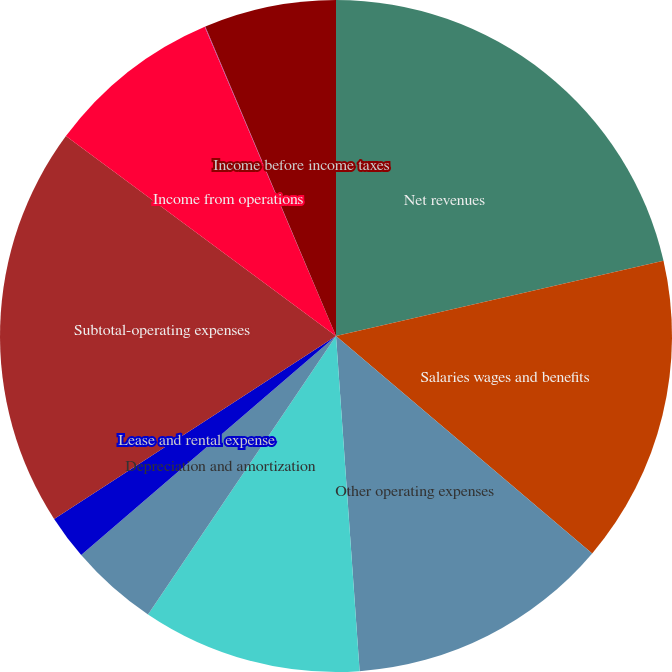Convert chart. <chart><loc_0><loc_0><loc_500><loc_500><pie_chart><fcel>Net revenues<fcel>Salaries wages and benefits<fcel>Other operating expenses<fcel>Supplies expense<fcel>Depreciation and amortization<fcel>Lease and rental expense<fcel>Subtotal-operating expenses<fcel>Income from operations<fcel>Interest expense net<fcel>Income before income taxes<nl><fcel>21.41%<fcel>14.79%<fcel>12.68%<fcel>10.57%<fcel>4.25%<fcel>2.14%<fcel>19.3%<fcel>8.47%<fcel>0.03%<fcel>6.36%<nl></chart> 